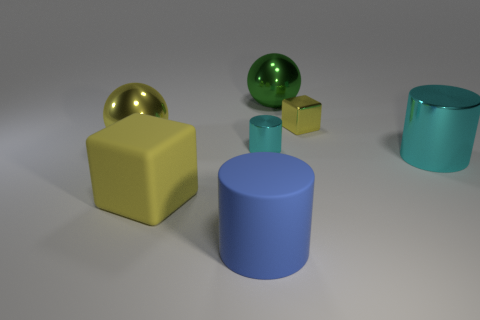Subtract all green blocks. Subtract all yellow balls. How many blocks are left? 2 Add 2 gray matte balls. How many objects exist? 9 Subtract all blocks. How many objects are left? 5 Subtract 0 brown balls. How many objects are left? 7 Subtract all small blue cylinders. Subtract all cyan metal cylinders. How many objects are left? 5 Add 4 matte things. How many matte things are left? 6 Add 7 large yellow things. How many large yellow things exist? 9 